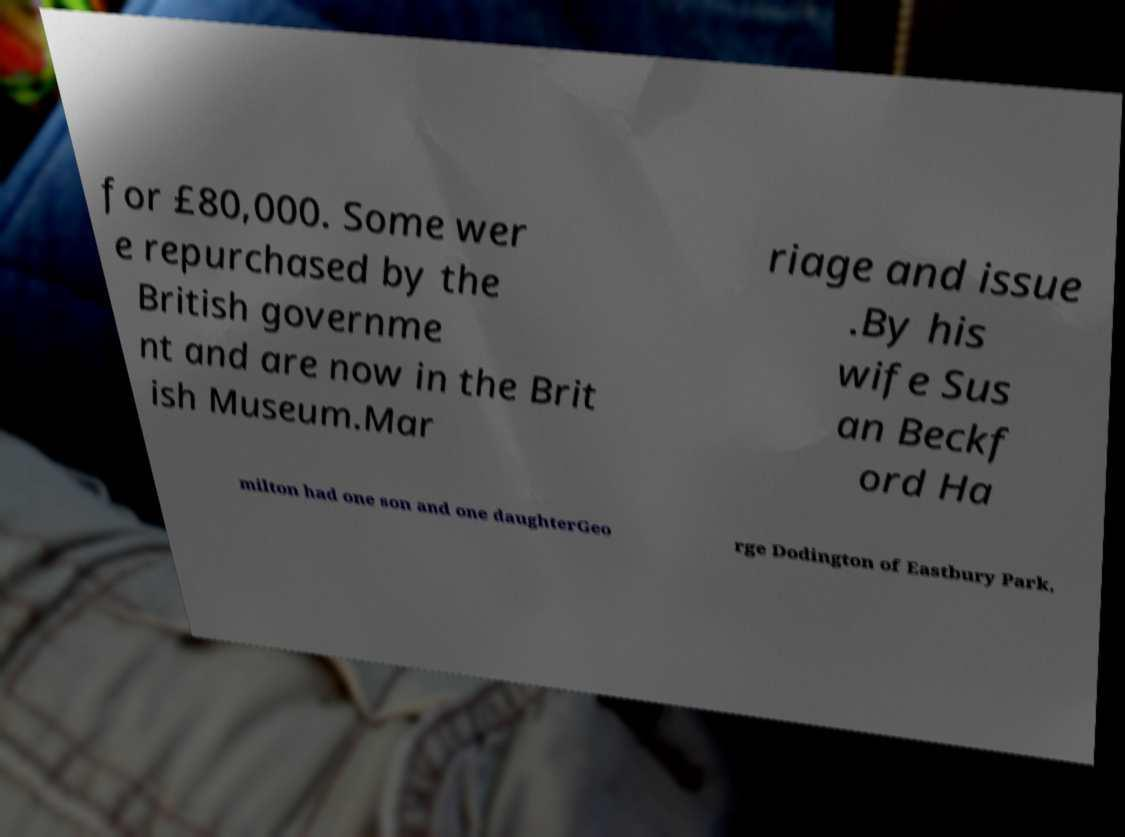Could you extract and type out the text from this image? for £80,000. Some wer e repurchased by the British governme nt and are now in the Brit ish Museum.Mar riage and issue .By his wife Sus an Beckf ord Ha milton had one son and one daughterGeo rge Dodington of Eastbury Park, 